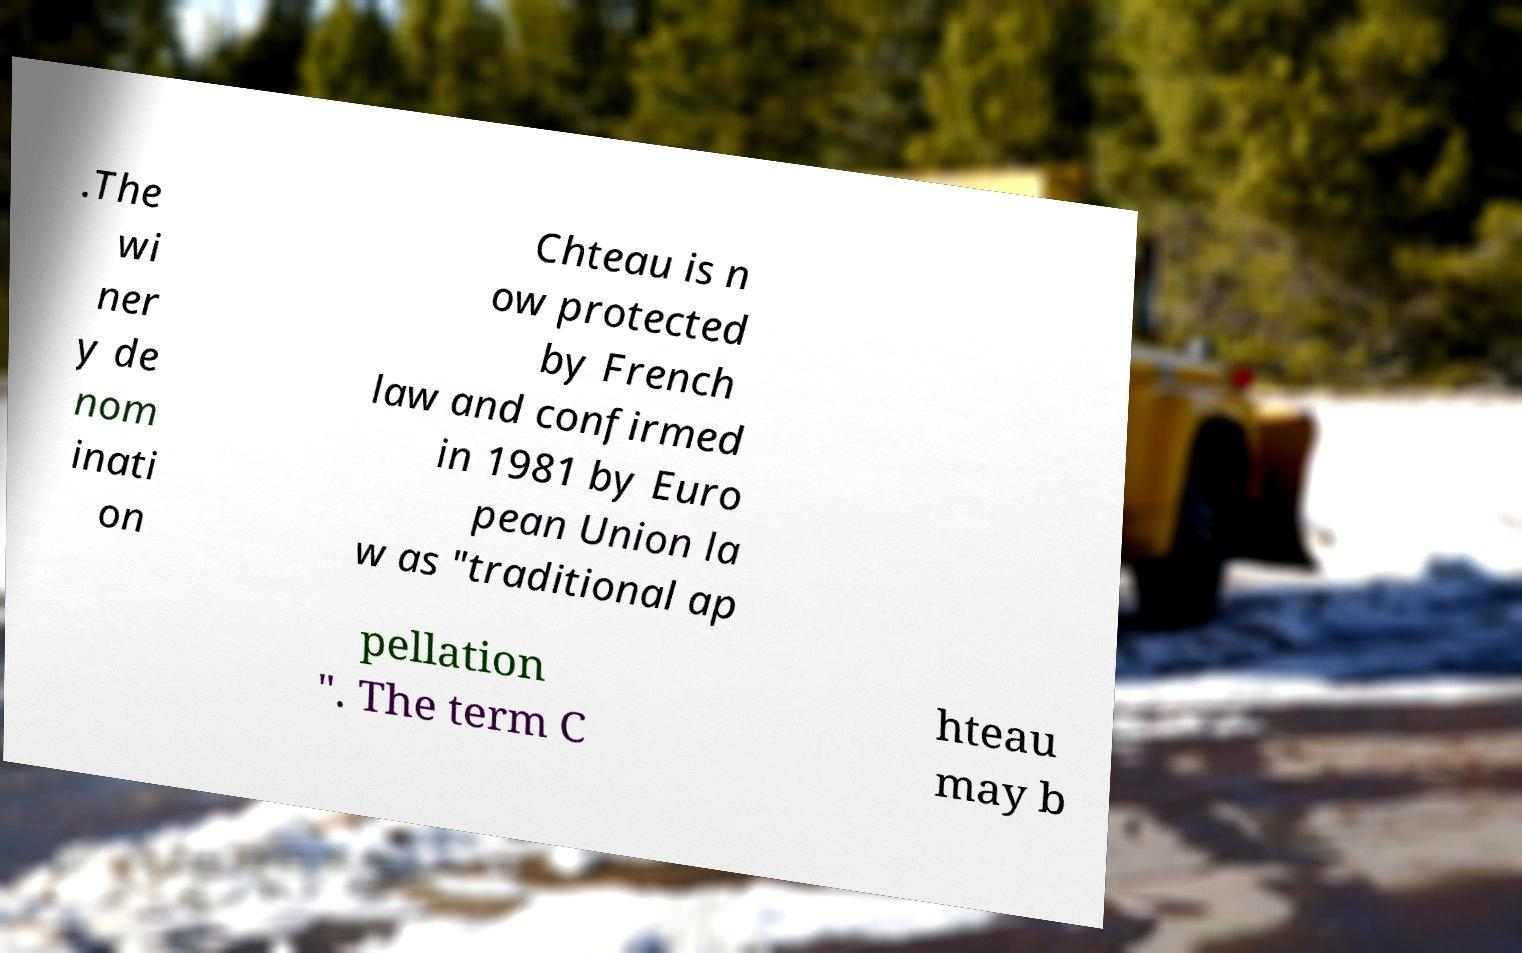For documentation purposes, I need the text within this image transcribed. Could you provide that? .The wi ner y de nom inati on Chteau is n ow protected by French law and confirmed in 1981 by Euro pean Union la w as "traditional ap pellation ". The term C hteau may b 